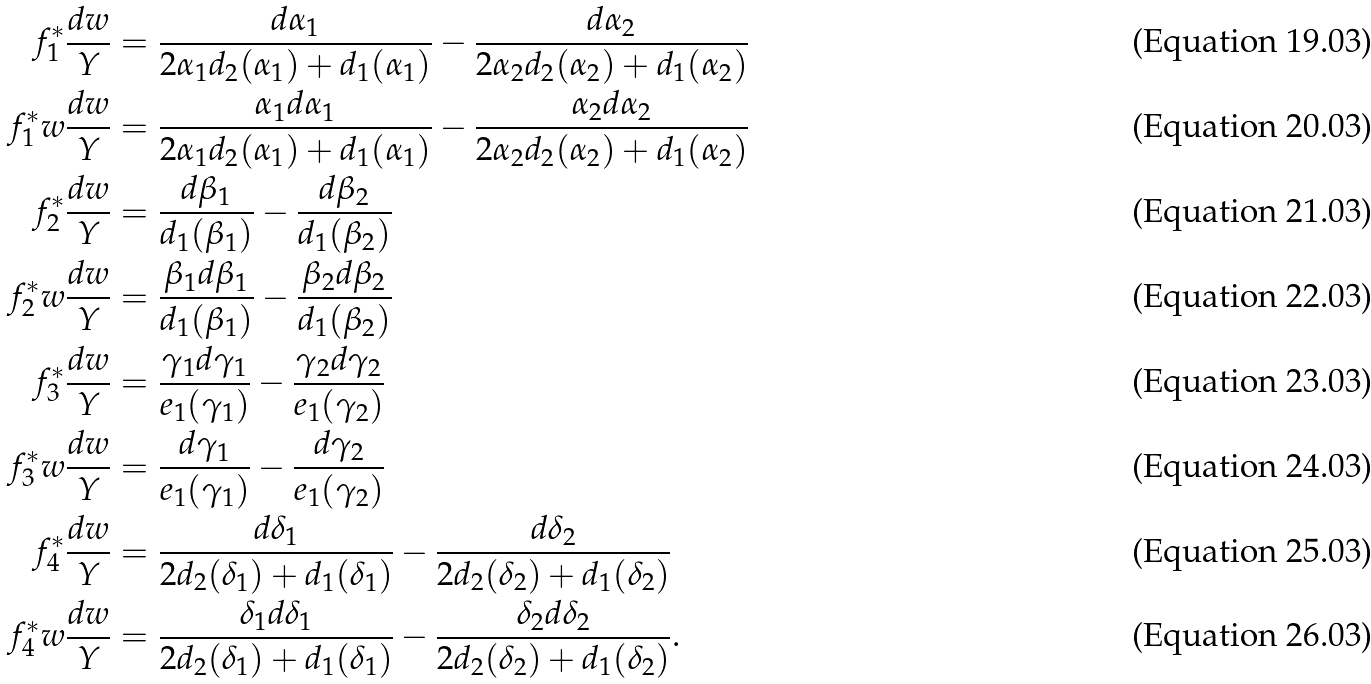<formula> <loc_0><loc_0><loc_500><loc_500>f _ { 1 } ^ { * } \frac { d w } { Y } & = \frac { d \alpha _ { 1 } } { 2 \alpha _ { 1 } d _ { 2 } ( \alpha _ { 1 } ) + d _ { 1 } ( \alpha _ { 1 } ) } - \frac { d \alpha _ { 2 } } { 2 \alpha _ { 2 } d _ { 2 } ( \alpha _ { 2 } ) + d _ { 1 } ( \alpha _ { 2 } ) } \\ f _ { 1 } ^ { * } w \frac { d w } { Y } & = \frac { \alpha _ { 1 } d \alpha _ { 1 } } { 2 \alpha _ { 1 } d _ { 2 } ( \alpha _ { 1 } ) + d _ { 1 } ( \alpha _ { 1 } ) } - \frac { \alpha _ { 2 } d \alpha _ { 2 } } { 2 \alpha _ { 2 } d _ { 2 } ( \alpha _ { 2 } ) + d _ { 1 } ( \alpha _ { 2 } ) } \\ f _ { 2 } ^ { * } \frac { d w } { Y } & = \frac { d \beta _ { 1 } } { d _ { 1 } ( \beta _ { 1 } ) } - \frac { d \beta _ { 2 } } { d _ { 1 } ( \beta _ { 2 } ) } \\ f _ { 2 } ^ { * } w \frac { d w } { Y } & = \frac { \beta _ { 1 } d \beta _ { 1 } } { d _ { 1 } ( \beta _ { 1 } ) } - \frac { \beta _ { 2 } d \beta _ { 2 } } { d _ { 1 } ( \beta _ { 2 } ) } \\ f _ { 3 } ^ { * } \frac { d w } { Y } & = \frac { \gamma _ { 1 } d \gamma _ { 1 } } { e _ { 1 } ( \gamma _ { 1 } ) } - \frac { \gamma _ { 2 } d \gamma _ { 2 } } { e _ { 1 } ( \gamma _ { 2 } ) } \\ f _ { 3 } ^ { * } w \frac { d w } { Y } & = \frac { d \gamma _ { 1 } } { e _ { 1 } ( \gamma _ { 1 } ) } - \frac { d \gamma _ { 2 } } { e _ { 1 } ( \gamma _ { 2 } ) } \\ f _ { 4 } ^ { * } \frac { d w } { Y } & = \frac { d \delta _ { 1 } } { 2 d _ { 2 } ( \delta _ { 1 } ) + d _ { 1 } ( \delta _ { 1 } ) } - \frac { d \delta _ { 2 } } { 2 d _ { 2 } ( \delta _ { 2 } ) + d _ { 1 } ( \delta _ { 2 } ) } \\ f _ { 4 } ^ { * } w \frac { d w } { Y } & = \frac { \delta _ { 1 } d \delta _ { 1 } } { 2 d _ { 2 } ( \delta _ { 1 } ) + d _ { 1 } ( \delta _ { 1 } ) } - \frac { \delta _ { 2 } d \delta _ { 2 } } { 2 d _ { 2 } ( \delta _ { 2 } ) + d _ { 1 } ( \delta _ { 2 } ) } .</formula> 